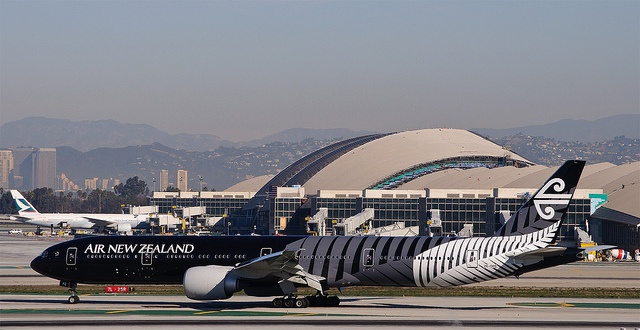Describe the objects in this image and their specific colors. I can see airplane in darkgray, black, gray, and lightgray tones and airplane in darkgray, lightgray, black, and gray tones in this image. 